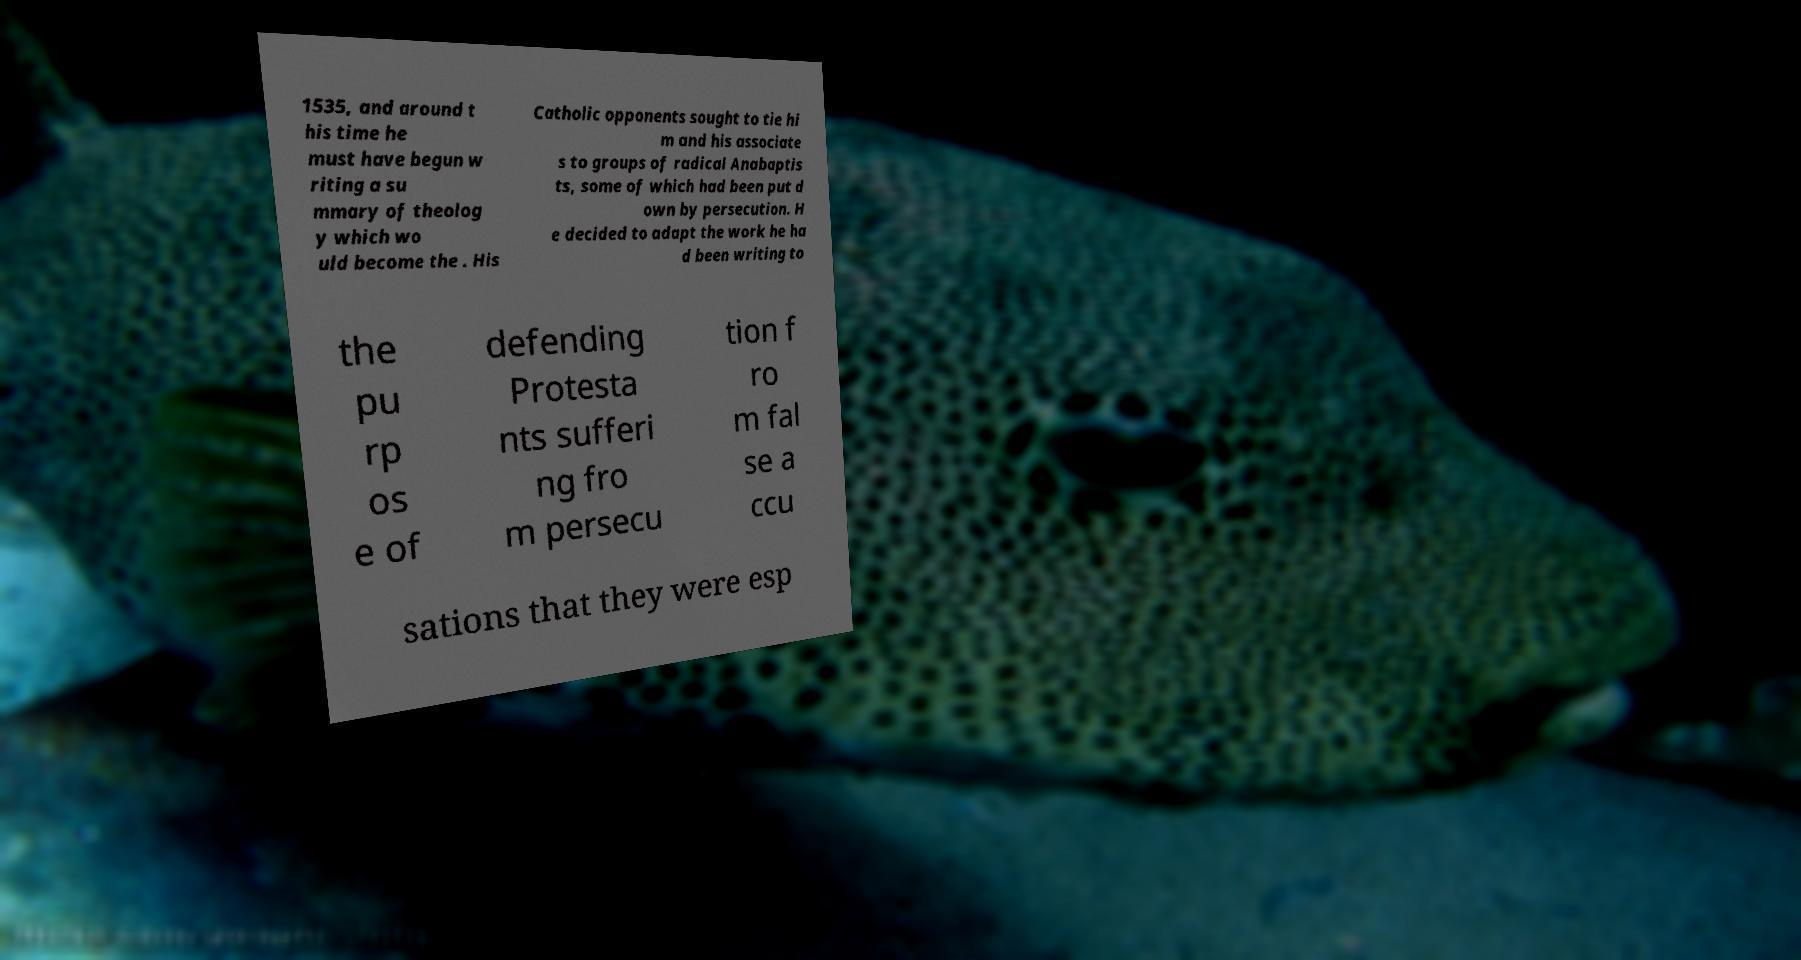Please identify and transcribe the text found in this image. 1535, and around t his time he must have begun w riting a su mmary of theolog y which wo uld become the . His Catholic opponents sought to tie hi m and his associate s to groups of radical Anabaptis ts, some of which had been put d own by persecution. H e decided to adapt the work he ha d been writing to the pu rp os e of defending Protesta nts sufferi ng fro m persecu tion f ro m fal se a ccu sations that they were esp 